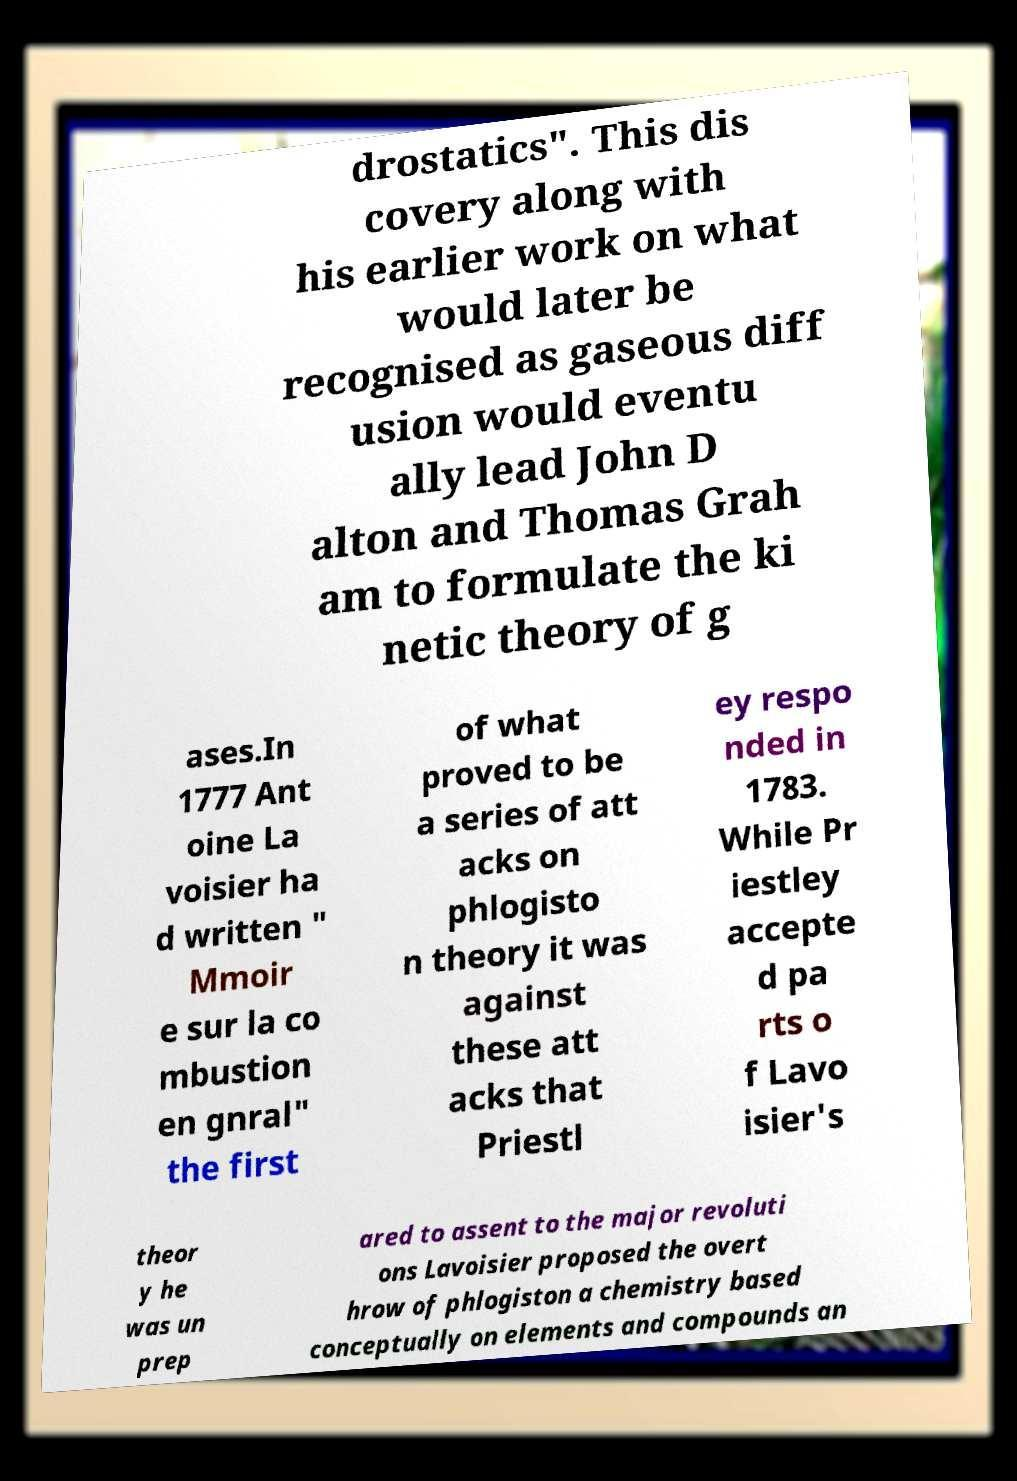Can you read and provide the text displayed in the image?This photo seems to have some interesting text. Can you extract and type it out for me? drostatics". This dis covery along with his earlier work on what would later be recognised as gaseous diff usion would eventu ally lead John D alton and Thomas Grah am to formulate the ki netic theory of g ases.In 1777 Ant oine La voisier ha d written " Mmoir e sur la co mbustion en gnral" the first of what proved to be a series of att acks on phlogisto n theory it was against these att acks that Priestl ey respo nded in 1783. While Pr iestley accepte d pa rts o f Lavo isier's theor y he was un prep ared to assent to the major revoluti ons Lavoisier proposed the overt hrow of phlogiston a chemistry based conceptually on elements and compounds an 